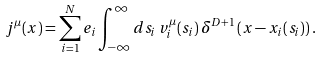Convert formula to latex. <formula><loc_0><loc_0><loc_500><loc_500>j ^ { \mu } ( x ) = \sum _ { i = 1 } ^ { N } e _ { i } \int _ { - \infty } ^ { \infty } d s _ { i } \, v _ { i } ^ { \mu } ( s _ { i } ) \, \delta ^ { D + 1 } \left ( x - x _ { i } ( s _ { i } ) \right ) .</formula> 